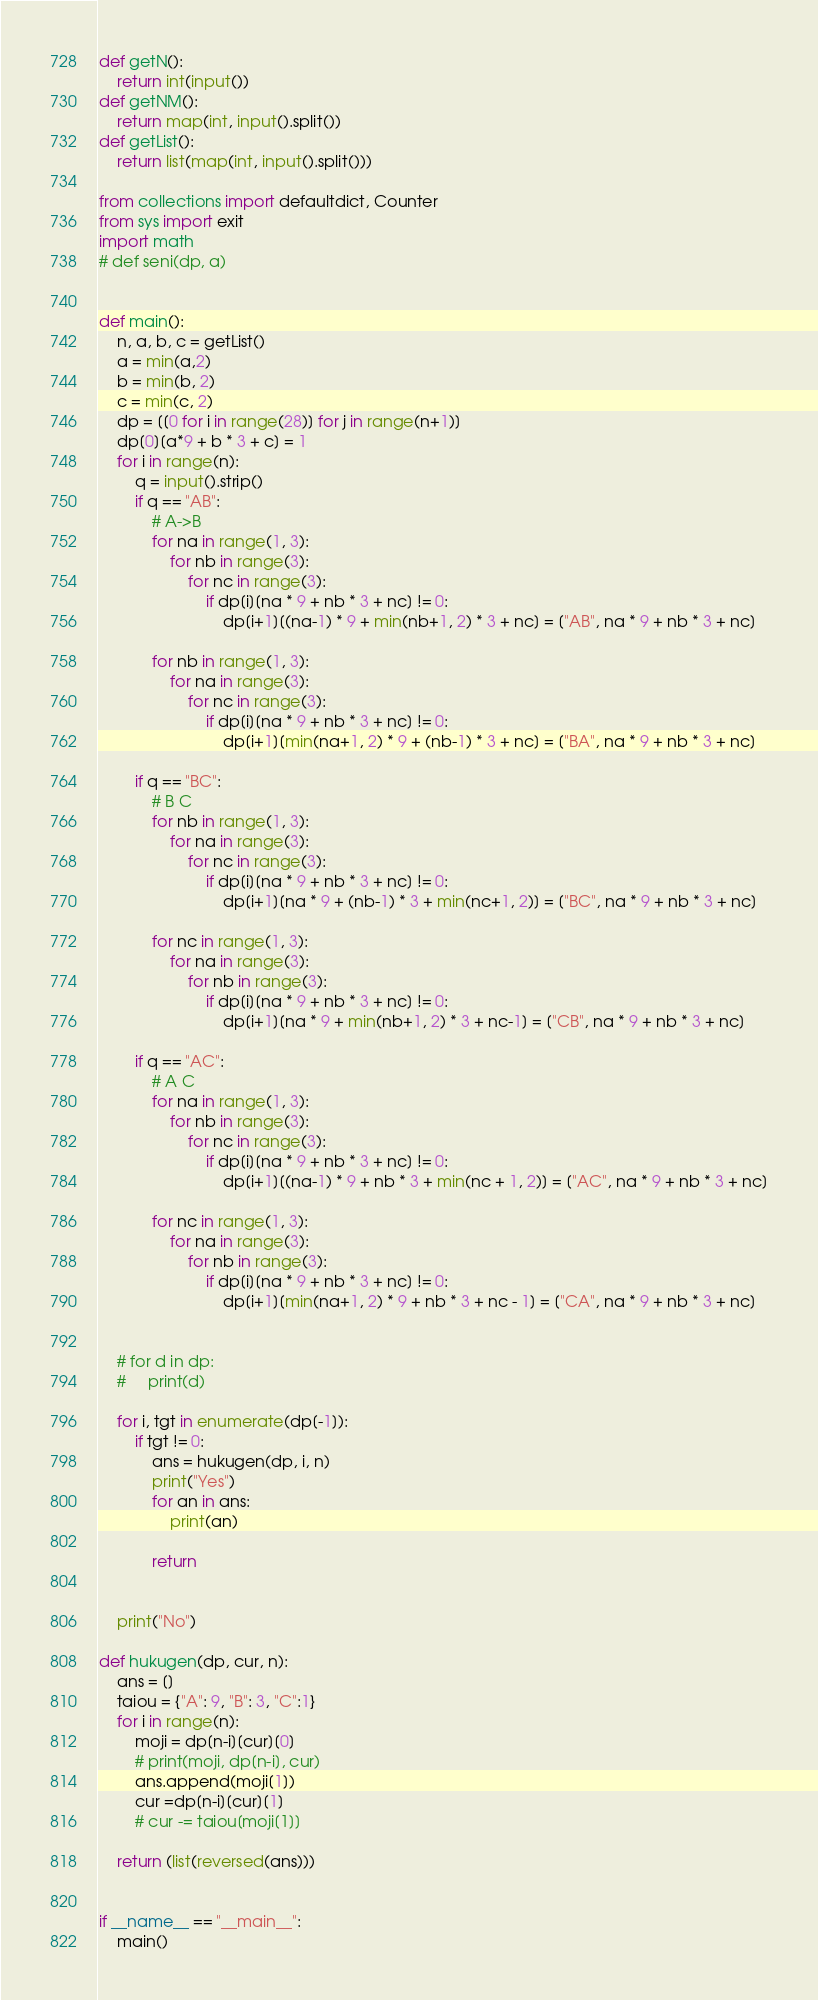Convert code to text. <code><loc_0><loc_0><loc_500><loc_500><_Python_>def getN():
    return int(input())
def getNM():
    return map(int, input().split())
def getList():
    return list(map(int, input().split()))

from collections import defaultdict, Counter
from sys import exit
import math
# def seni(dp, a)


def main():
    n, a, b, c = getList()
    a = min(a,2)
    b = min(b, 2)
    c = min(c, 2)
    dp = [[0 for i in range(28)] for j in range(n+1)]
    dp[0][a*9 + b * 3 + c] = 1
    for i in range(n):
        q = input().strip()
        if q == "AB":
            # A->B
            for na in range(1, 3):
                for nb in range(3):
                    for nc in range(3):
                        if dp[i][na * 9 + nb * 3 + nc] != 0:
                            dp[i+1][(na-1) * 9 + min(nb+1, 2) * 3 + nc] = ["AB", na * 9 + nb * 3 + nc]

            for nb in range(1, 3):
                for na in range(3):
                    for nc in range(3):
                        if dp[i][na * 9 + nb * 3 + nc] != 0:
                            dp[i+1][min(na+1, 2) * 9 + (nb-1) * 3 + nc] = ["BA", na * 9 + nb * 3 + nc]

        if q == "BC":
            # B C
            for nb in range(1, 3):
                for na in range(3):
                    for nc in range(3):
                        if dp[i][na * 9 + nb * 3 + nc] != 0:
                            dp[i+1][na * 9 + (nb-1) * 3 + min(nc+1, 2)] = ["BC", na * 9 + nb * 3 + nc]

            for nc in range(1, 3):
                for na in range(3):
                    for nb in range(3):
                        if dp[i][na * 9 + nb * 3 + nc] != 0:
                            dp[i+1][na * 9 + min(nb+1, 2) * 3 + nc-1] = ["CB", na * 9 + nb * 3 + nc]

        if q == "AC":
            # A C
            for na in range(1, 3):
                for nb in range(3):
                    for nc in range(3):
                        if dp[i][na * 9 + nb * 3 + nc] != 0:
                            dp[i+1][(na-1) * 9 + nb * 3 + min(nc + 1, 2)] = ["AC", na * 9 + nb * 3 + nc]

            for nc in range(1, 3):
                for na in range(3):
                    for nb in range(3):
                        if dp[i][na * 9 + nb * 3 + nc] != 0:
                            dp[i+1][min(na+1, 2) * 9 + nb * 3 + nc - 1] = ["CA", na * 9 + nb * 3 + nc]


    # for d in dp:
    #     print(d)

    for i, tgt in enumerate(dp[-1]):
        if tgt != 0:
            ans = hukugen(dp, i, n)
            print("Yes")
            for an in ans:
                print(an)

            return


    print("No")

def hukugen(dp, cur, n):
    ans = []
    taiou = {"A": 9, "B": 3, "C":1}
    for i in range(n):
        moji = dp[n-i][cur][0]
        # print(moji, dp[n-i], cur)
        ans.append(moji[1])
        cur =dp[n-i][cur][1]
        # cur -= taiou[moji[1]]

    return (list(reversed(ans)))


if __name__ == "__main__":
    main()</code> 